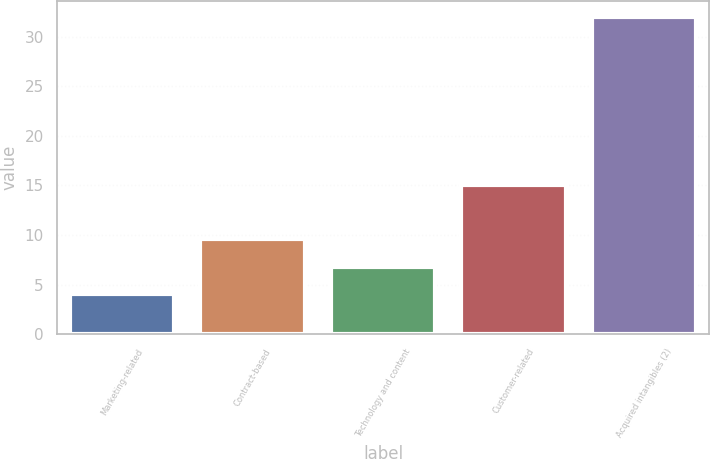Convert chart to OTSL. <chart><loc_0><loc_0><loc_500><loc_500><bar_chart><fcel>Marketing-related<fcel>Contract-based<fcel>Technology and content<fcel>Customer-related<fcel>Acquired intangibles (2)<nl><fcel>4<fcel>9.6<fcel>6.8<fcel>15<fcel>32<nl></chart> 